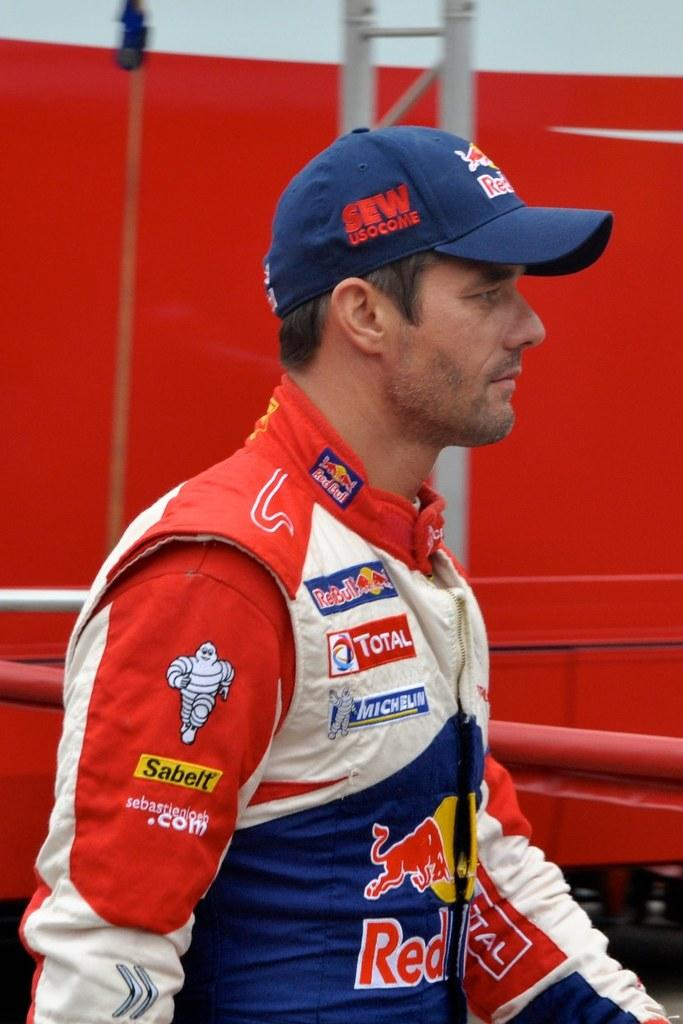<image>
Relay a brief, clear account of the picture shown. a sleeve that has the word sabelt on it 